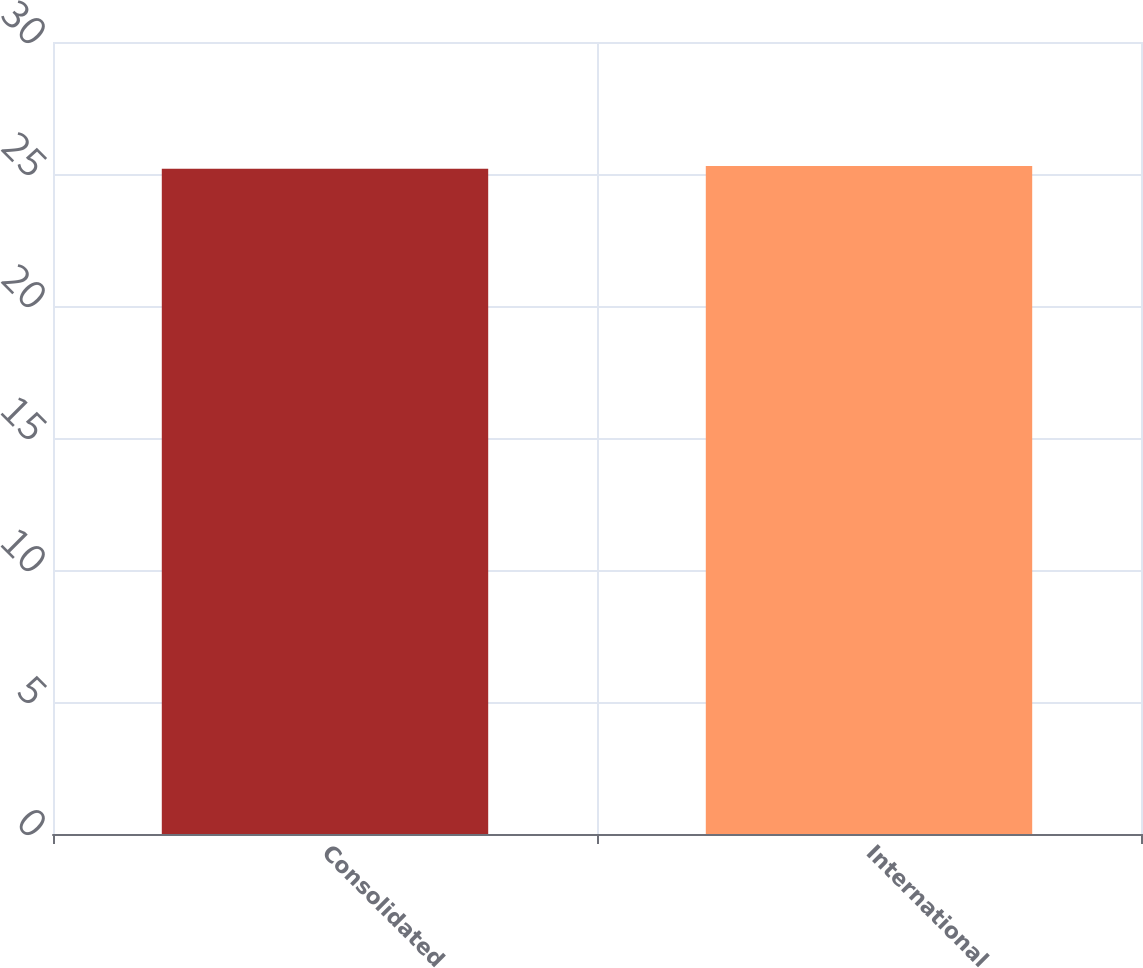<chart> <loc_0><loc_0><loc_500><loc_500><bar_chart><fcel>Consolidated<fcel>International<nl><fcel>25.2<fcel>25.3<nl></chart> 